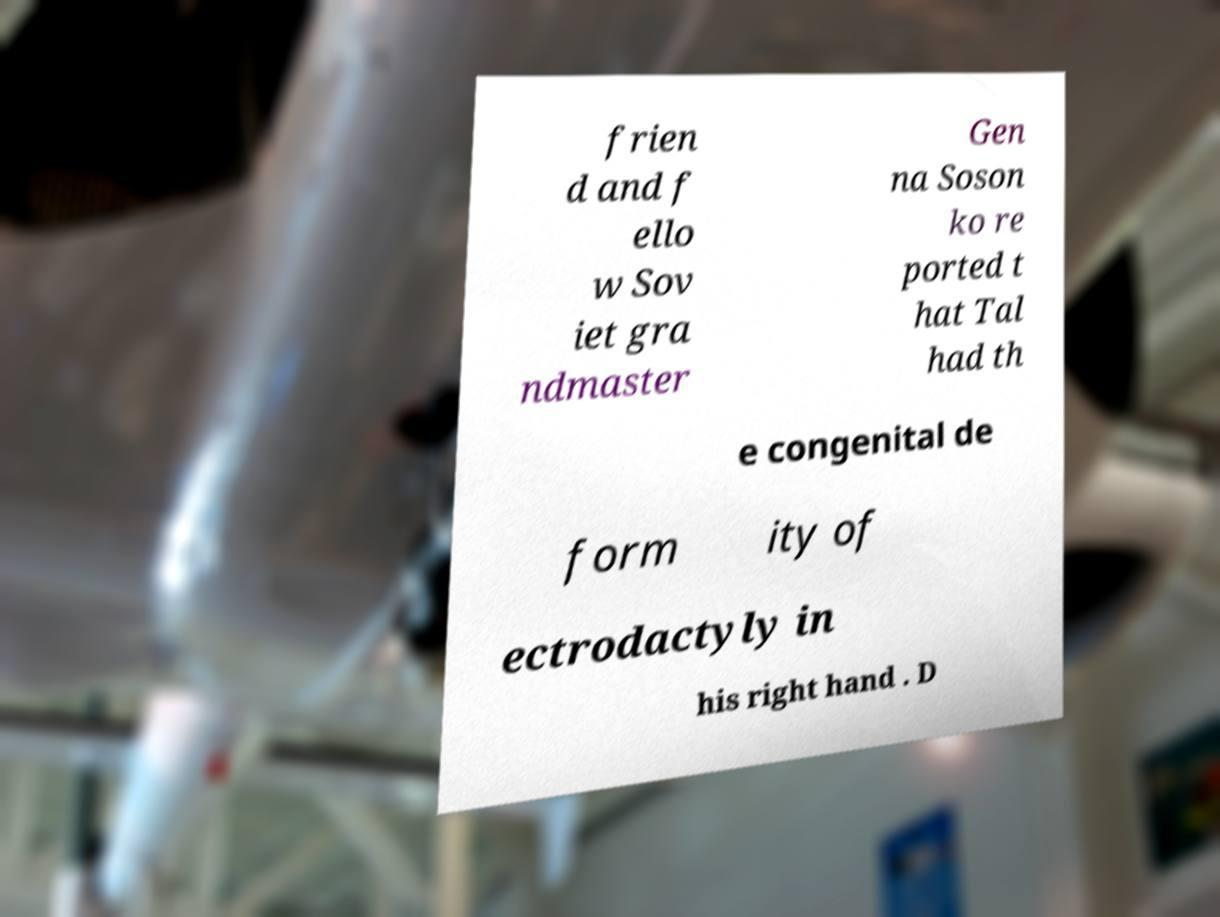Please identify and transcribe the text found in this image. frien d and f ello w Sov iet gra ndmaster Gen na Soson ko re ported t hat Tal had th e congenital de form ity of ectrodactyly in his right hand . D 